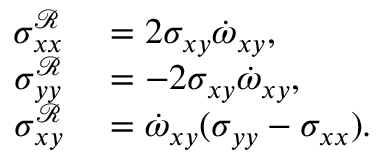<formula> <loc_0><loc_0><loc_500><loc_500>\begin{array} { r l } { \sigma _ { x x } ^ { \mathcal { R } } } & = 2 \sigma _ { x y } \dot { \omega } _ { x y } , } \\ { \sigma _ { y y } ^ { \mathcal { R } } } & = - 2 \sigma _ { x y } \dot { \omega } _ { x y } , } \\ { \sigma _ { x y } ^ { \mathcal { R } } } & = \dot { \omega } _ { x y } ( \sigma _ { y y } - \sigma _ { x x } ) . } \end{array}</formula> 